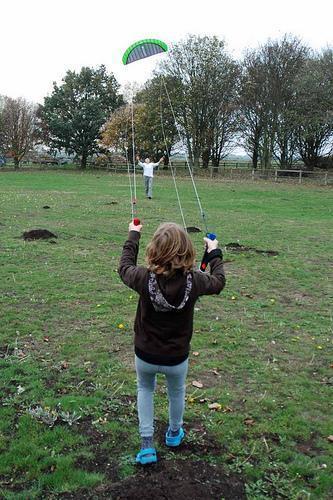How many hands is the child using?
Give a very brief answer. 2. How many people are there?
Give a very brief answer. 1. 